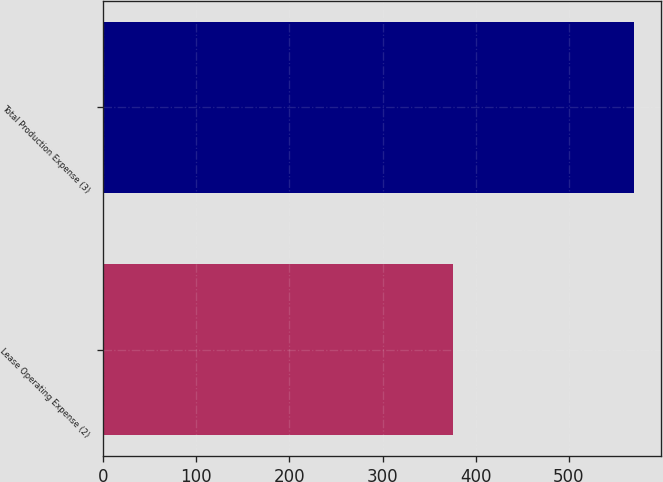Convert chart. <chart><loc_0><loc_0><loc_500><loc_500><bar_chart><fcel>Lease Operating Expense (2)<fcel>Total Production Expense (3)<nl><fcel>376<fcel>570<nl></chart> 